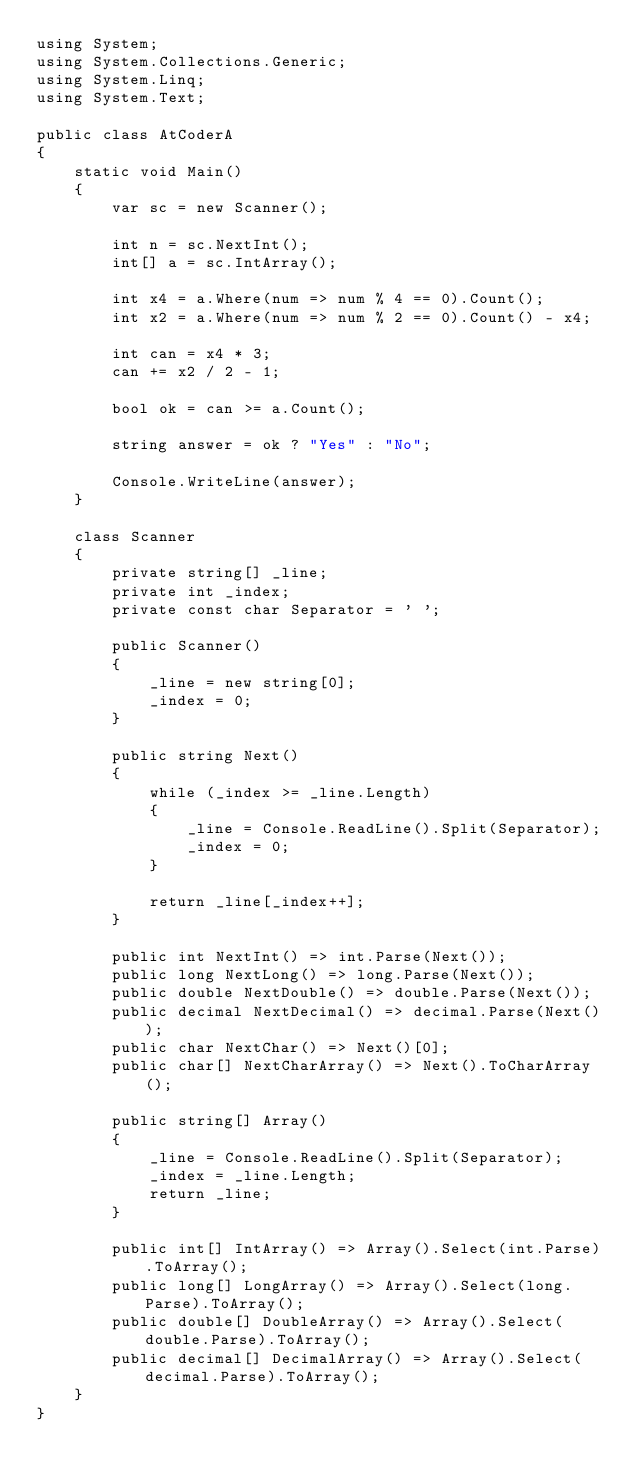<code> <loc_0><loc_0><loc_500><loc_500><_C#_>using System;
using System.Collections.Generic;
using System.Linq;
using System.Text;

public class AtCoderA
{
    static void Main()
    {
        var sc = new Scanner();

        int n = sc.NextInt();
        int[] a = sc.IntArray();

        int x4 = a.Where(num => num % 4 == 0).Count();
        int x2 = a.Where(num => num % 2 == 0).Count() - x4;

        int can = x4 * 3;
        can += x2 / 2 - 1;

        bool ok = can >= a.Count();

        string answer = ok ? "Yes" : "No";

        Console.WriteLine(answer);
    }

    class Scanner
    {
        private string[] _line;
        private int _index;
        private const char Separator = ' ';

        public Scanner()
        {
            _line = new string[0];
            _index = 0;
        }

        public string Next()
        {
            while (_index >= _line.Length)
            {
                _line = Console.ReadLine().Split(Separator);
                _index = 0;
            }

            return _line[_index++];
        }

        public int NextInt() => int.Parse(Next());
        public long NextLong() => long.Parse(Next());
        public double NextDouble() => double.Parse(Next());
        public decimal NextDecimal() => decimal.Parse(Next());
        public char NextChar() => Next()[0];
        public char[] NextCharArray() => Next().ToCharArray();

        public string[] Array()
        {
            _line = Console.ReadLine().Split(Separator);
            _index = _line.Length;
            return _line;
        }

        public int[] IntArray() => Array().Select(int.Parse).ToArray();
        public long[] LongArray() => Array().Select(long.Parse).ToArray();
        public double[] DoubleArray() => Array().Select(double.Parse).ToArray();
        public decimal[] DecimalArray() => Array().Select(decimal.Parse).ToArray();
    }
}
</code> 